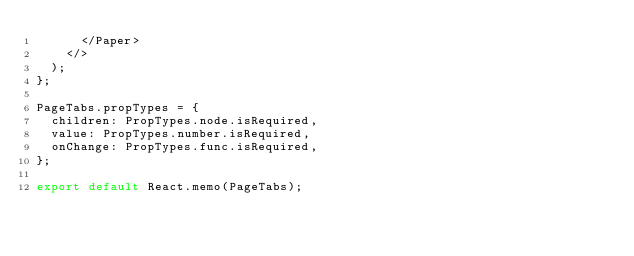Convert code to text. <code><loc_0><loc_0><loc_500><loc_500><_JavaScript_>      </Paper>
    </>
  );
};

PageTabs.propTypes = {
  children: PropTypes.node.isRequired,
  value: PropTypes.number.isRequired,
  onChange: PropTypes.func.isRequired,
};

export default React.memo(PageTabs);
</code> 